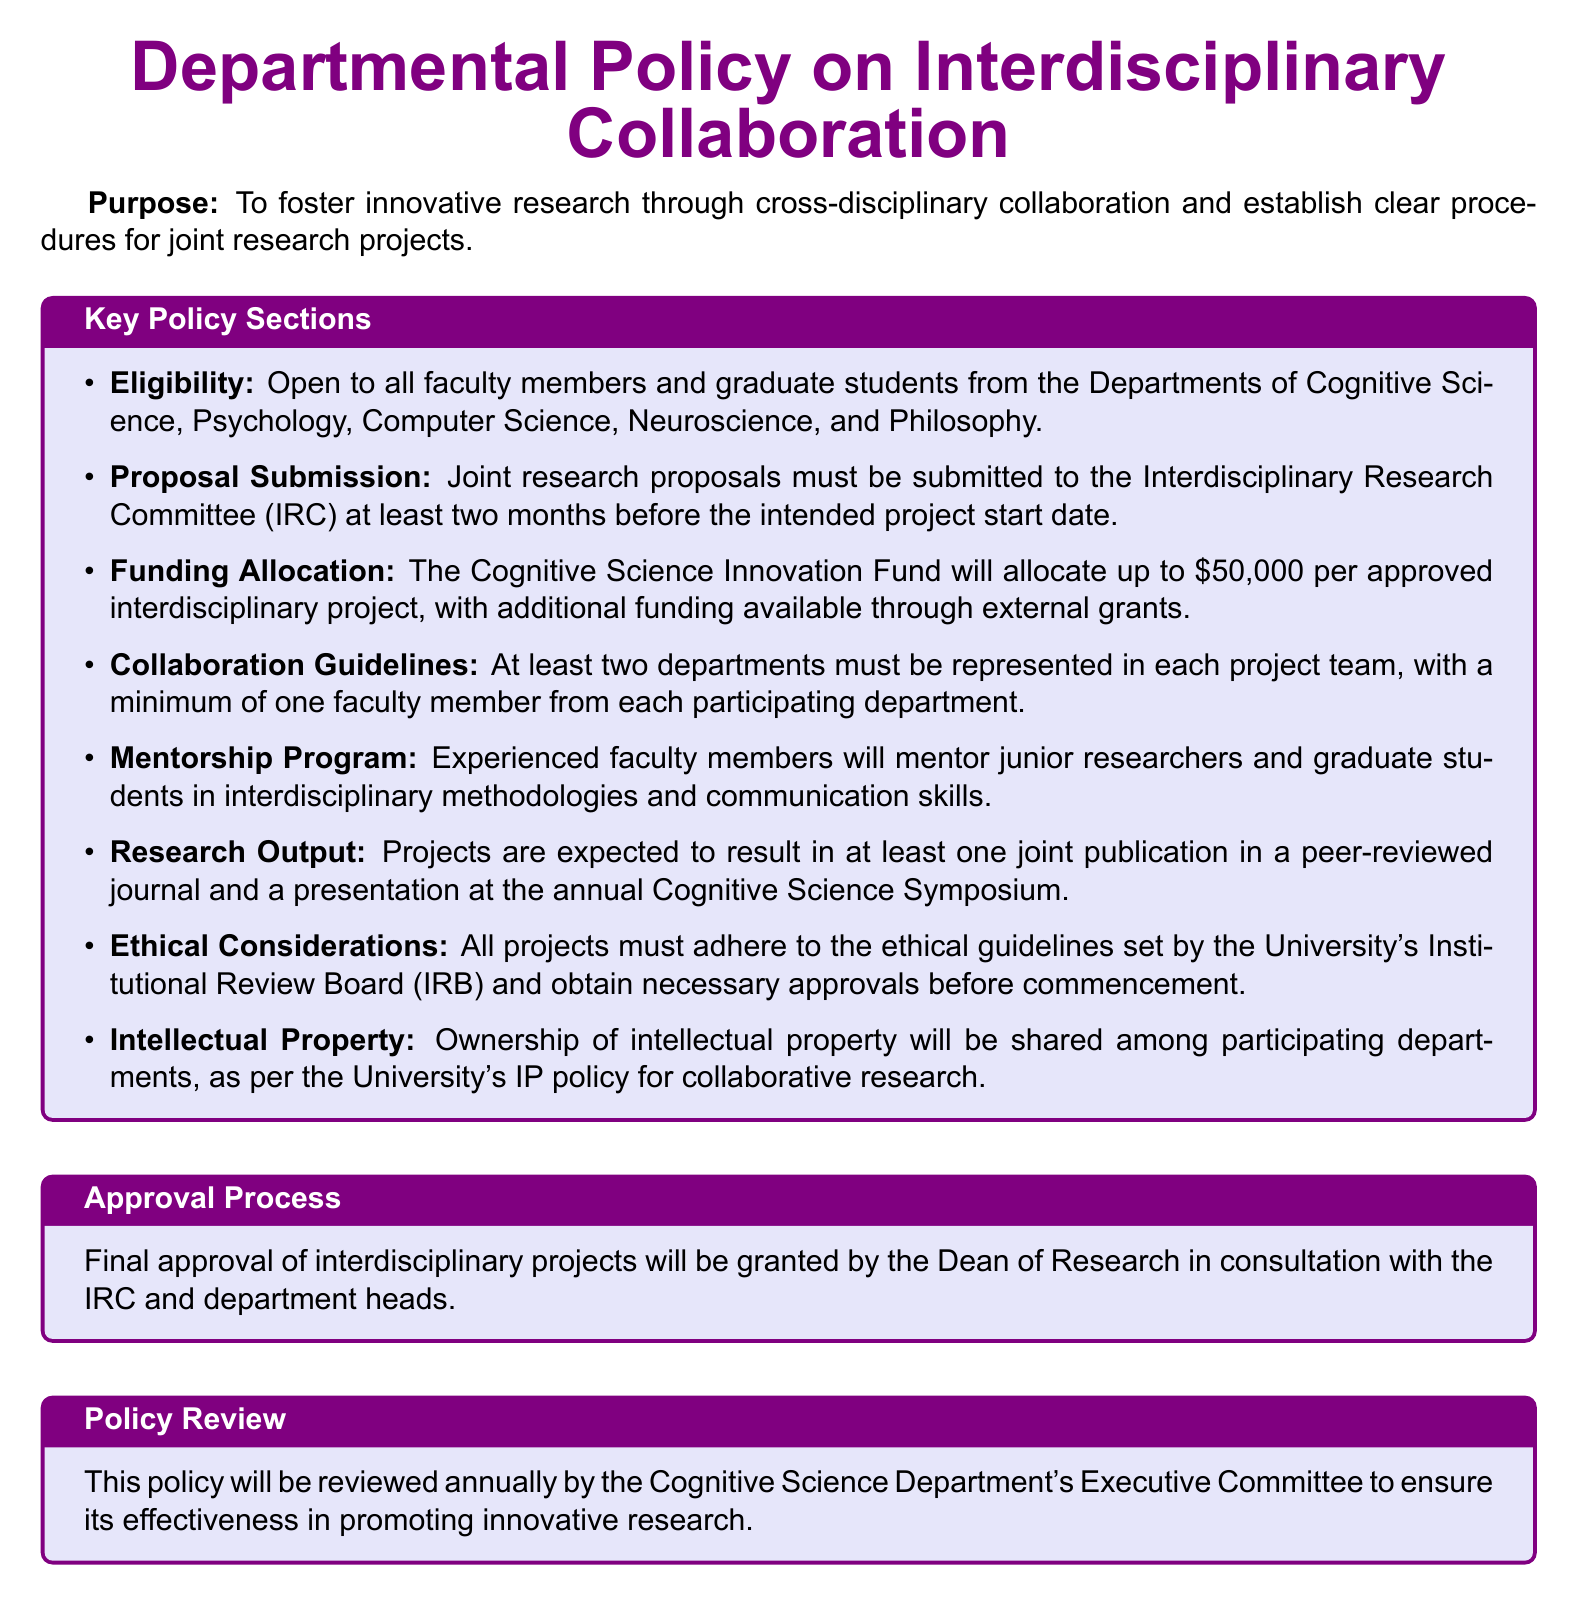What is the eligibility for joint research proposals? The eligibility criteria detail which faculty members and graduate students can participate in joint research proposals, specifically naming the relevant departments.
Answer: All faculty members and graduate students from the Departments of Cognitive Science, Psychology, Computer Science, Neuroscience, and Philosophy How much funding is available per approved project? The funding section outlines the maximum financial support offered for interdisciplinary projects.
Answer: Up to $50,000 What is the minimum number of departments required in a project team? The collaboration guidelines specify the necessary departmental representation in a project team.
Answer: At least two departments Who grants final approval for interdisciplinary projects? The approval section identifies the entity responsible for granting final approval for projects described in the policy.
Answer: Dean of Research What is a requirement for research output? The research output section states what projects are expected to produce upon completion.
Answer: At least one joint publication in a peer-reviewed journal Which program will assist junior researchers? The mentorship section mentions a specific program aimed at supporting junior researchers in their work.
Answer: Mentorship Program 